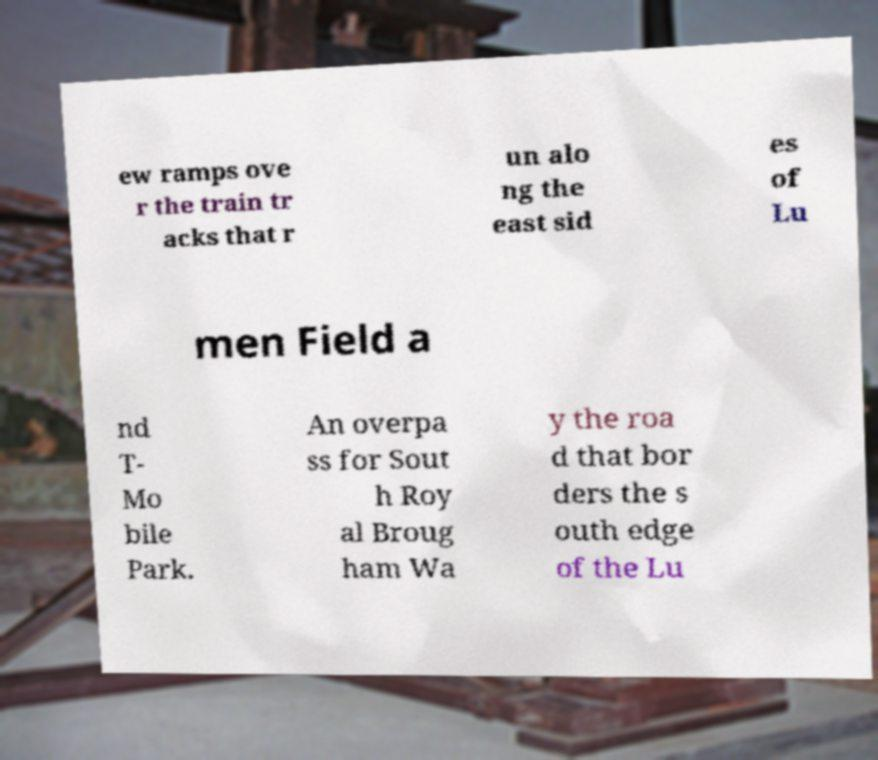Could you assist in decoding the text presented in this image and type it out clearly? ew ramps ove r the train tr acks that r un alo ng the east sid es of Lu men Field a nd T- Mo bile Park. An overpa ss for Sout h Roy al Broug ham Wa y the roa d that bor ders the s outh edge of the Lu 